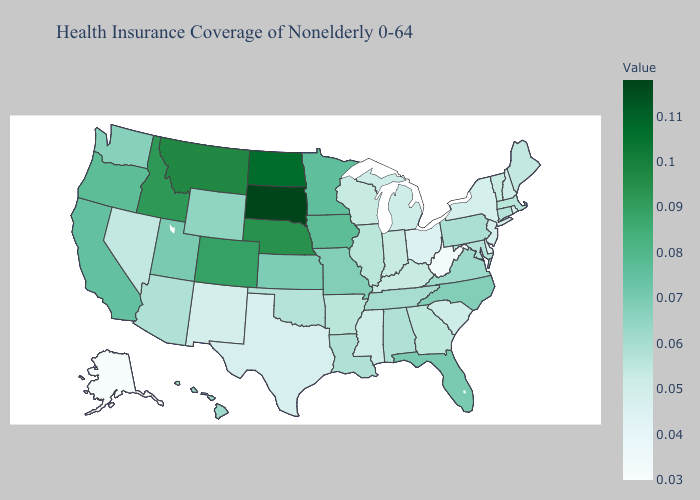Which states have the lowest value in the USA?
Answer briefly. Alaska. Does Massachusetts have the lowest value in the USA?
Keep it brief. No. Among the states that border Kentucky , does Ohio have the lowest value?
Concise answer only. No. Does Alaska have the lowest value in the USA?
Concise answer only. Yes. Does South Dakota have a higher value than Michigan?
Be succinct. Yes. Which states have the lowest value in the West?
Give a very brief answer. Alaska. Does South Dakota have the highest value in the USA?
Keep it brief. Yes. Does the map have missing data?
Keep it brief. No. 